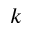Convert formula to latex. <formula><loc_0><loc_0><loc_500><loc_500>k</formula> 